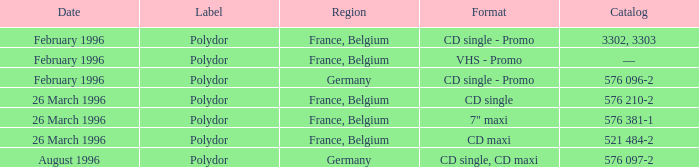Specify the region linked to the catalog entry 576 097- Germany. 